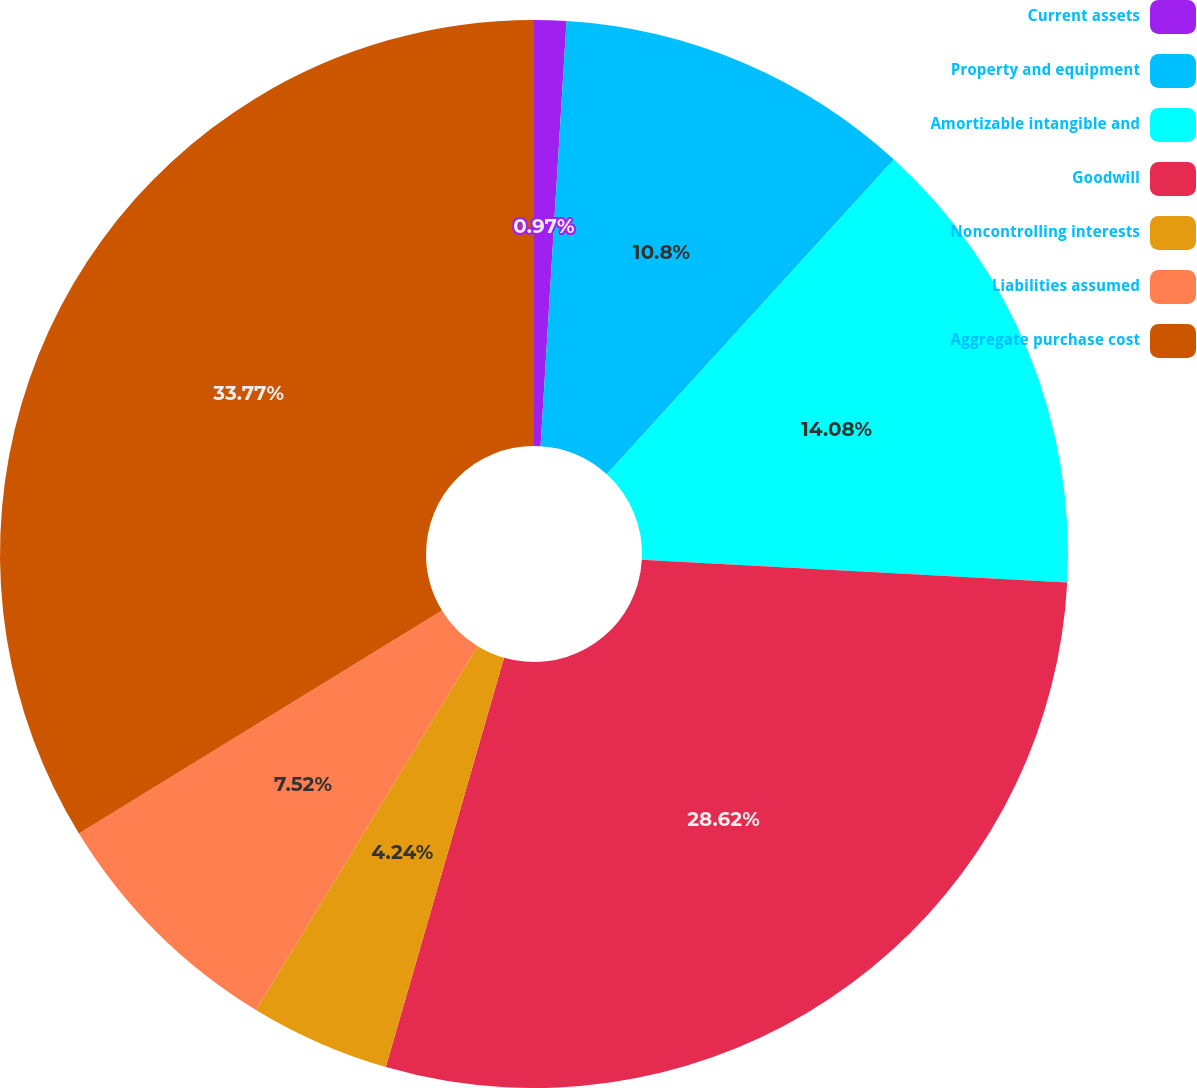<chart> <loc_0><loc_0><loc_500><loc_500><pie_chart><fcel>Current assets<fcel>Property and equipment<fcel>Amortizable intangible and<fcel>Goodwill<fcel>Noncontrolling interests<fcel>Liabilities assumed<fcel>Aggregate purchase cost<nl><fcel>0.97%<fcel>10.8%<fcel>14.08%<fcel>28.62%<fcel>4.24%<fcel>7.52%<fcel>33.76%<nl></chart> 